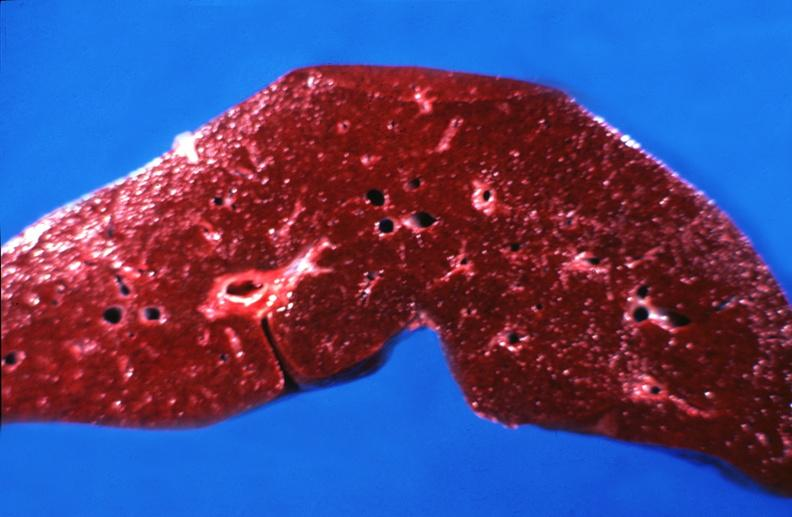s marked present?
Answer the question using a single word or phrase. No 